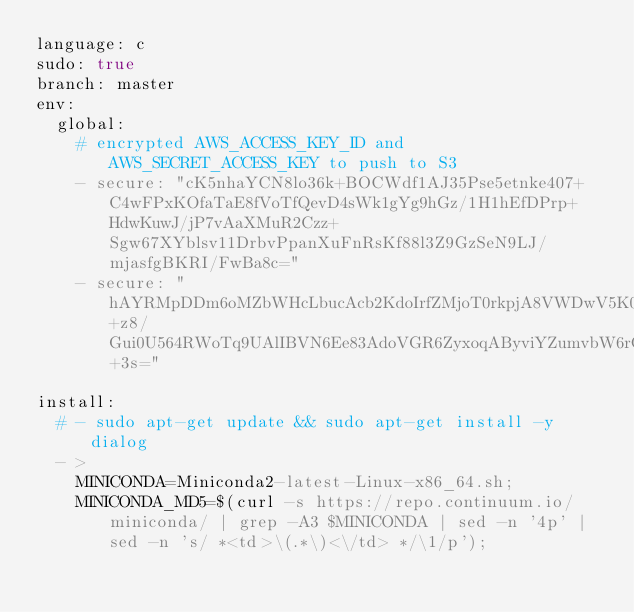Convert code to text. <code><loc_0><loc_0><loc_500><loc_500><_YAML_>language: c
sudo: true
branch: master
env:
  global:
    # encrypted AWS_ACCESS_KEY_ID and AWS_SECRET_ACCESS_KEY to push to S3
    - secure: "cK5nhaYCN8lo36k+BOCWdf1AJ35Pse5etnke407+C4wFPxKOfaTaE8fVoTfQevD4sWk1gYg9hGz/1H1hEfDPrp+HdwKuwJ/jP7vAaXMuR2Czz+Sgw67XYblsv11DrbvPpanXuFnRsKf88l3Z9GzSeN9LJ/mjasfgBKRI/FwBa8c="
    - secure: "hAYRMpDDm6oMZbWHcLbucAcb2KdoIrfZMjoT0rkpjA8VWDwV5K07tcacziVeiR1MgtmHARx0ZI9vrO5Qu+z8/Gui0U564RWoTq9UAlIBVN6Ee83AdoVGR6ZyxoqAByviYZumvbW6rG6B1u9qyEJoZ27tHPSrwm71YNpqkzVE+3s="

install:
  # - sudo apt-get update && sudo apt-get install -y dialog
  - >
    MINICONDA=Miniconda2-latest-Linux-x86_64.sh;
    MINICONDA_MD5=$(curl -s https://repo.continuum.io/miniconda/ | grep -A3 $MINICONDA | sed -n '4p' | sed -n 's/ *<td>\(.*\)<\/td> */\1/p');</code> 